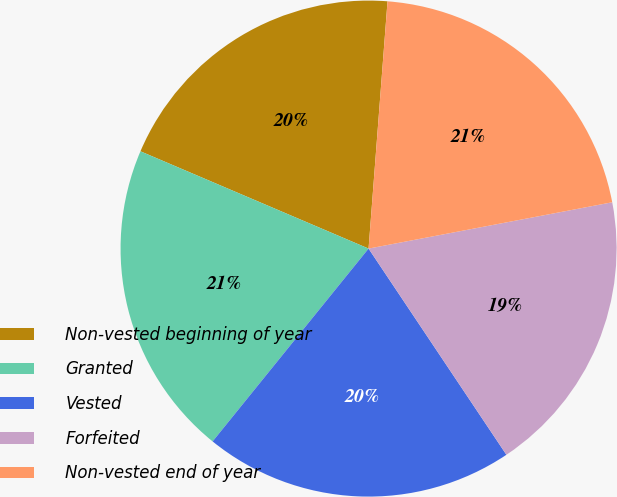Convert chart to OTSL. <chart><loc_0><loc_0><loc_500><loc_500><pie_chart><fcel>Non-vested beginning of year<fcel>Granted<fcel>Vested<fcel>Forfeited<fcel>Non-vested end of year<nl><fcel>19.8%<fcel>20.59%<fcel>20.2%<fcel>18.61%<fcel>20.79%<nl></chart> 